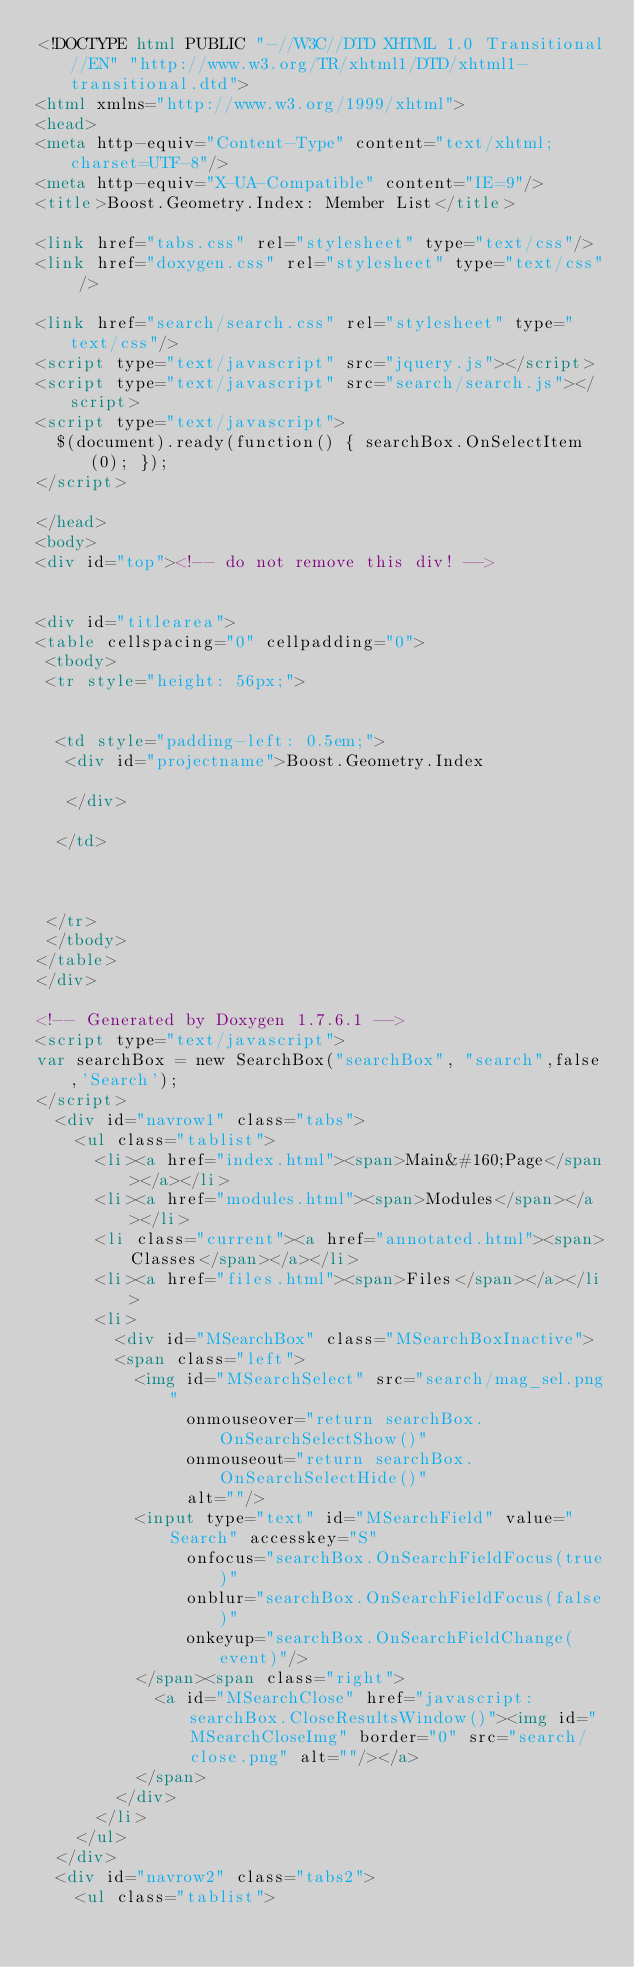<code> <loc_0><loc_0><loc_500><loc_500><_HTML_><!DOCTYPE html PUBLIC "-//W3C//DTD XHTML 1.0 Transitional//EN" "http://www.w3.org/TR/xhtml1/DTD/xhtml1-transitional.dtd">
<html xmlns="http://www.w3.org/1999/xhtml">
<head>
<meta http-equiv="Content-Type" content="text/xhtml;charset=UTF-8"/>
<meta http-equiv="X-UA-Compatible" content="IE=9"/>
<title>Boost.Geometry.Index: Member List</title>

<link href="tabs.css" rel="stylesheet" type="text/css"/>
<link href="doxygen.css" rel="stylesheet" type="text/css" />

<link href="search/search.css" rel="stylesheet" type="text/css"/>
<script type="text/javascript" src="jquery.js"></script>
<script type="text/javascript" src="search/search.js"></script>
<script type="text/javascript">
  $(document).ready(function() { searchBox.OnSelectItem(0); });
</script>

</head>
<body>
<div id="top"><!-- do not remove this div! -->


<div id="titlearea">
<table cellspacing="0" cellpadding="0">
 <tbody>
 <tr style="height: 56px;">
  
  
  <td style="padding-left: 0.5em;">
   <div id="projectname">Boost.Geometry.Index
   
   </div>
   
  </td>
  
  
  
 </tr>
 </tbody>
</table>
</div>

<!-- Generated by Doxygen 1.7.6.1 -->
<script type="text/javascript">
var searchBox = new SearchBox("searchBox", "search",false,'Search');
</script>
  <div id="navrow1" class="tabs">
    <ul class="tablist">
      <li><a href="index.html"><span>Main&#160;Page</span></a></li>
      <li><a href="modules.html"><span>Modules</span></a></li>
      <li class="current"><a href="annotated.html"><span>Classes</span></a></li>
      <li><a href="files.html"><span>Files</span></a></li>
      <li>
        <div id="MSearchBox" class="MSearchBoxInactive">
        <span class="left">
          <img id="MSearchSelect" src="search/mag_sel.png"
               onmouseover="return searchBox.OnSearchSelectShow()"
               onmouseout="return searchBox.OnSearchSelectHide()"
               alt=""/>
          <input type="text" id="MSearchField" value="Search" accesskey="S"
               onfocus="searchBox.OnSearchFieldFocus(true)" 
               onblur="searchBox.OnSearchFieldFocus(false)" 
               onkeyup="searchBox.OnSearchFieldChange(event)"/>
          </span><span class="right">
            <a id="MSearchClose" href="javascript:searchBox.CloseResultsWindow()"><img id="MSearchCloseImg" border="0" src="search/close.png" alt=""/></a>
          </span>
        </div>
      </li>
    </ul>
  </div>
  <div id="navrow2" class="tabs2">
    <ul class="tablist"></code> 